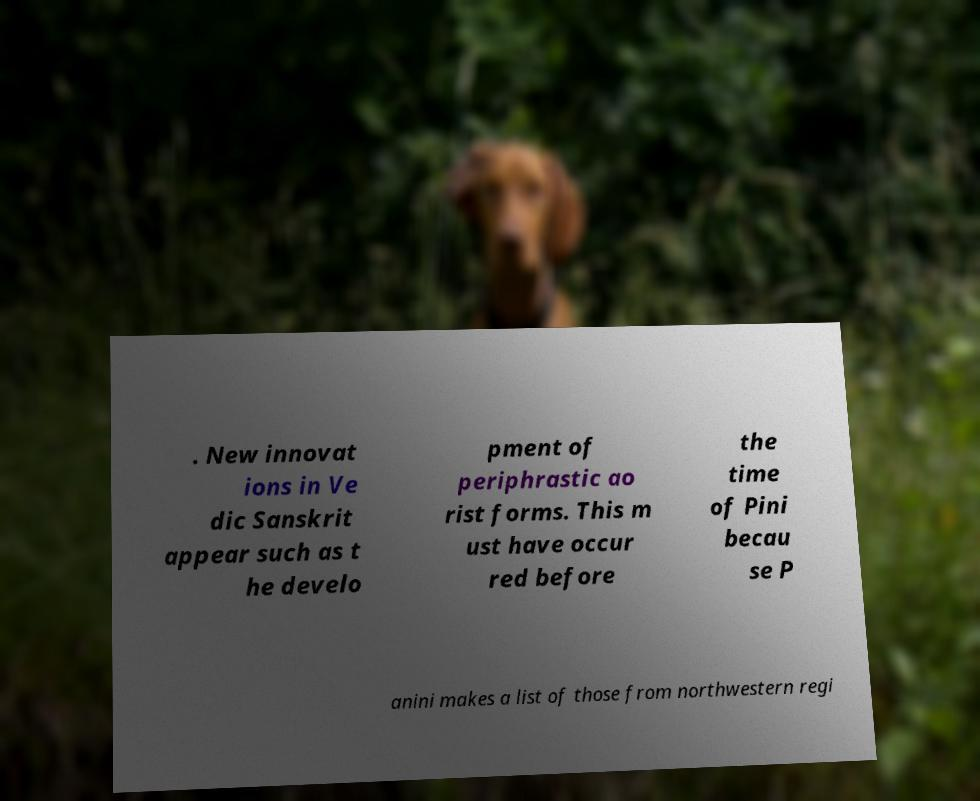I need the written content from this picture converted into text. Can you do that? . New innovat ions in Ve dic Sanskrit appear such as t he develo pment of periphrastic ao rist forms. This m ust have occur red before the time of Pini becau se P anini makes a list of those from northwestern regi 